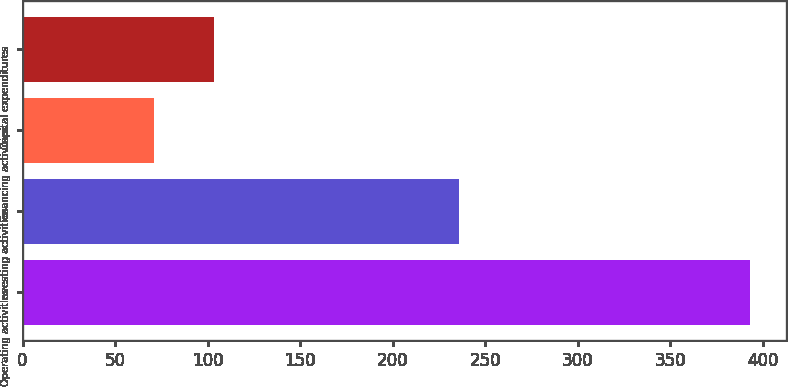Convert chart. <chart><loc_0><loc_0><loc_500><loc_500><bar_chart><fcel>Operating activities<fcel>Investing activities<fcel>Financing activities<fcel>Capital expenditures<nl><fcel>393<fcel>236<fcel>71<fcel>103.2<nl></chart> 